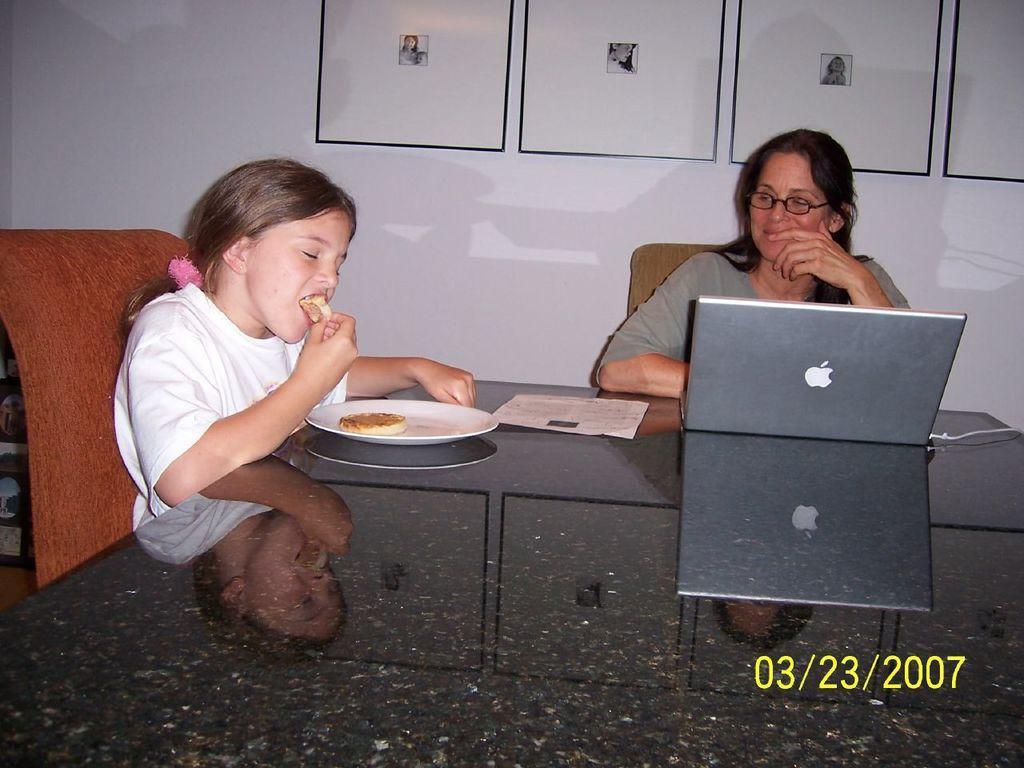Can you describe this image briefly? In the center of the image there is a table. On the left there is a girl eating food. In the center there is a lady sitting. There is a laptop, paper and plate of food placed on the table. In the background there is a screen. 